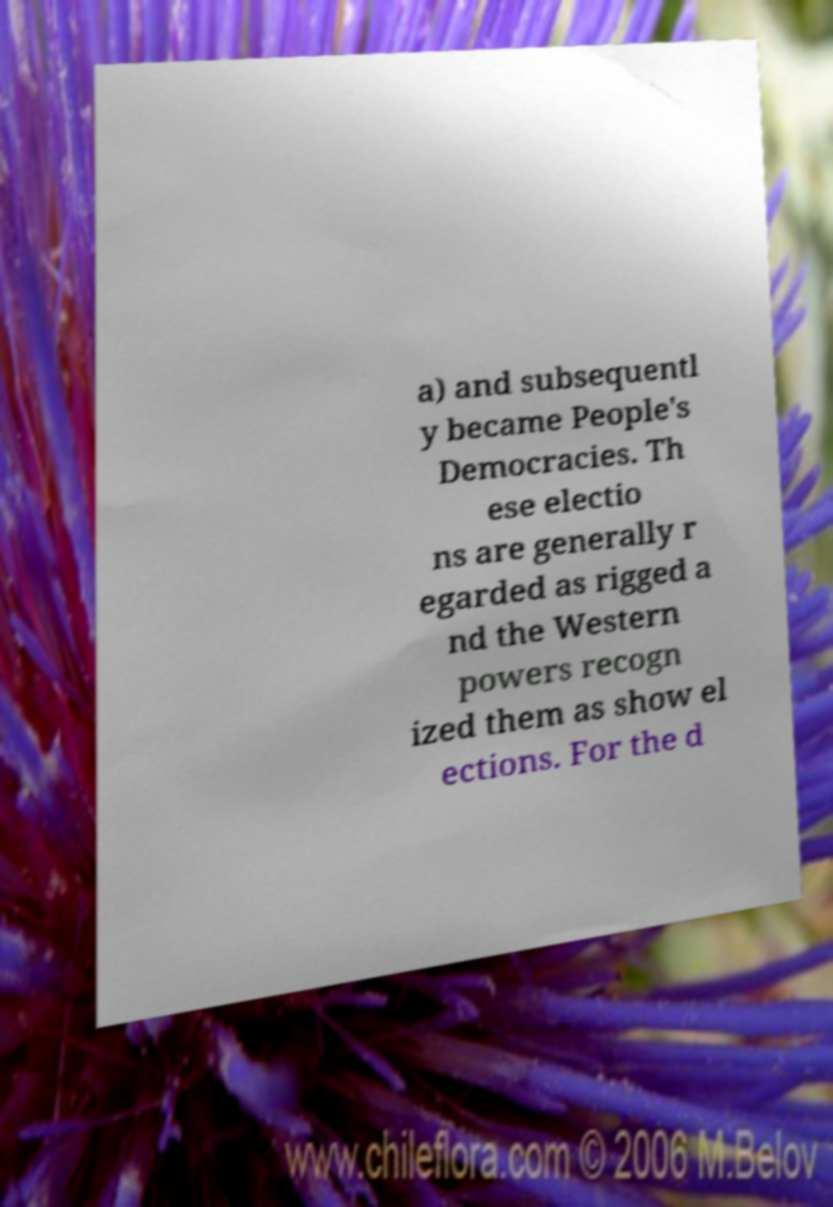Could you extract and type out the text from this image? a) and subsequentl y became People's Democracies. Th ese electio ns are generally r egarded as rigged a nd the Western powers recogn ized them as show el ections. For the d 